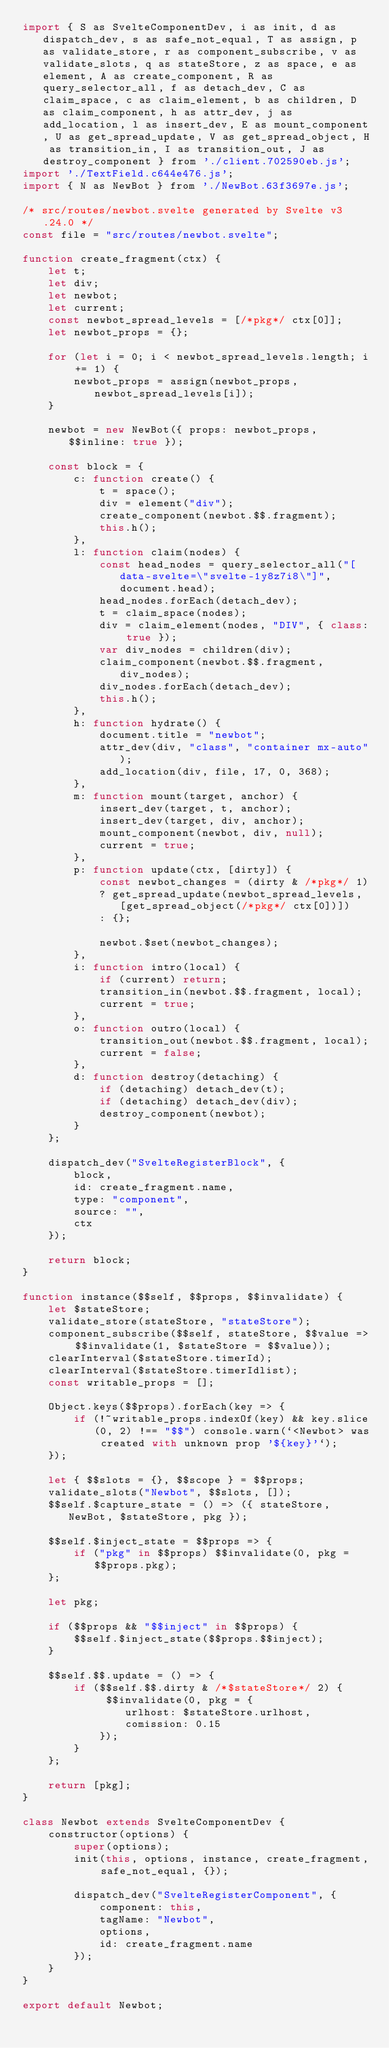<code> <loc_0><loc_0><loc_500><loc_500><_JavaScript_>import { S as SvelteComponentDev, i as init, d as dispatch_dev, s as safe_not_equal, T as assign, p as validate_store, r as component_subscribe, v as validate_slots, q as stateStore, z as space, e as element, A as create_component, R as query_selector_all, f as detach_dev, C as claim_space, c as claim_element, b as children, D as claim_component, h as attr_dev, j as add_location, l as insert_dev, E as mount_component, U as get_spread_update, V as get_spread_object, H as transition_in, I as transition_out, J as destroy_component } from './client.702590eb.js';
import './TextField.c644e476.js';
import { N as NewBot } from './NewBot.63f3697e.js';

/* src/routes/newbot.svelte generated by Svelte v3.24.0 */
const file = "src/routes/newbot.svelte";

function create_fragment(ctx) {
	let t;
	let div;
	let newbot;
	let current;
	const newbot_spread_levels = [/*pkg*/ ctx[0]];
	let newbot_props = {};

	for (let i = 0; i < newbot_spread_levels.length; i += 1) {
		newbot_props = assign(newbot_props, newbot_spread_levels[i]);
	}

	newbot = new NewBot({ props: newbot_props, $$inline: true });

	const block = {
		c: function create() {
			t = space();
			div = element("div");
			create_component(newbot.$$.fragment);
			this.h();
		},
		l: function claim(nodes) {
			const head_nodes = query_selector_all("[data-svelte=\"svelte-1y8z7i8\"]", document.head);
			head_nodes.forEach(detach_dev);
			t = claim_space(nodes);
			div = claim_element(nodes, "DIV", { class: true });
			var div_nodes = children(div);
			claim_component(newbot.$$.fragment, div_nodes);
			div_nodes.forEach(detach_dev);
			this.h();
		},
		h: function hydrate() {
			document.title = "newbot";
			attr_dev(div, "class", "container mx-auto");
			add_location(div, file, 17, 0, 368);
		},
		m: function mount(target, anchor) {
			insert_dev(target, t, anchor);
			insert_dev(target, div, anchor);
			mount_component(newbot, div, null);
			current = true;
		},
		p: function update(ctx, [dirty]) {
			const newbot_changes = (dirty & /*pkg*/ 1)
			? get_spread_update(newbot_spread_levels, [get_spread_object(/*pkg*/ ctx[0])])
			: {};

			newbot.$set(newbot_changes);
		},
		i: function intro(local) {
			if (current) return;
			transition_in(newbot.$$.fragment, local);
			current = true;
		},
		o: function outro(local) {
			transition_out(newbot.$$.fragment, local);
			current = false;
		},
		d: function destroy(detaching) {
			if (detaching) detach_dev(t);
			if (detaching) detach_dev(div);
			destroy_component(newbot);
		}
	};

	dispatch_dev("SvelteRegisterBlock", {
		block,
		id: create_fragment.name,
		type: "component",
		source: "",
		ctx
	});

	return block;
}

function instance($$self, $$props, $$invalidate) {
	let $stateStore;
	validate_store(stateStore, "stateStore");
	component_subscribe($$self, stateStore, $$value => $$invalidate(1, $stateStore = $$value));
	clearInterval($stateStore.timerId);
	clearInterval($stateStore.timerIdlist);
	const writable_props = [];

	Object.keys($$props).forEach(key => {
		if (!~writable_props.indexOf(key) && key.slice(0, 2) !== "$$") console.warn(`<Newbot> was created with unknown prop '${key}'`);
	});

	let { $$slots = {}, $$scope } = $$props;
	validate_slots("Newbot", $$slots, []);
	$$self.$capture_state = () => ({ stateStore, NewBot, $stateStore, pkg });

	$$self.$inject_state = $$props => {
		if ("pkg" in $$props) $$invalidate(0, pkg = $$props.pkg);
	};

	let pkg;

	if ($$props && "$$inject" in $$props) {
		$$self.$inject_state($$props.$$inject);
	}

	$$self.$$.update = () => {
		if ($$self.$$.dirty & /*$stateStore*/ 2) {
			 $$invalidate(0, pkg = {
				urlhost: $stateStore.urlhost,
				comission: 0.15
			});
		}
	};

	return [pkg];
}

class Newbot extends SvelteComponentDev {
	constructor(options) {
		super(options);
		init(this, options, instance, create_fragment, safe_not_equal, {});

		dispatch_dev("SvelteRegisterComponent", {
			component: this,
			tagName: "Newbot",
			options,
			id: create_fragment.name
		});
	}
}

export default Newbot;</code> 